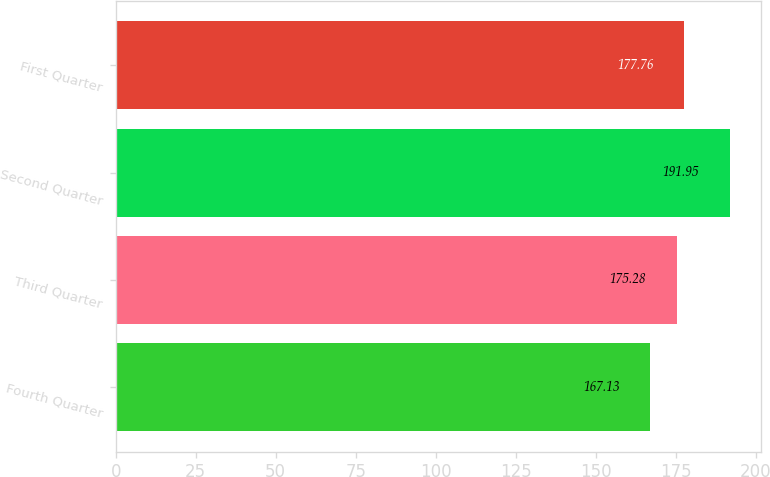Convert chart. <chart><loc_0><loc_0><loc_500><loc_500><bar_chart><fcel>Fourth Quarter<fcel>Third Quarter<fcel>Second Quarter<fcel>First Quarter<nl><fcel>167.13<fcel>175.28<fcel>191.95<fcel>177.76<nl></chart> 